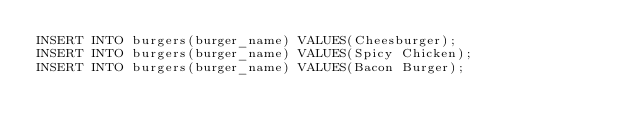Convert code to text. <code><loc_0><loc_0><loc_500><loc_500><_SQL_>INSERT INTO burgers(burger_name) VALUES(Cheesburger);
INSERT INTO burgers(burger_name) VALUES(Spicy Chicken); 
INSERT INTO burgers(burger_name) VALUES(Bacon Burger); 
</code> 